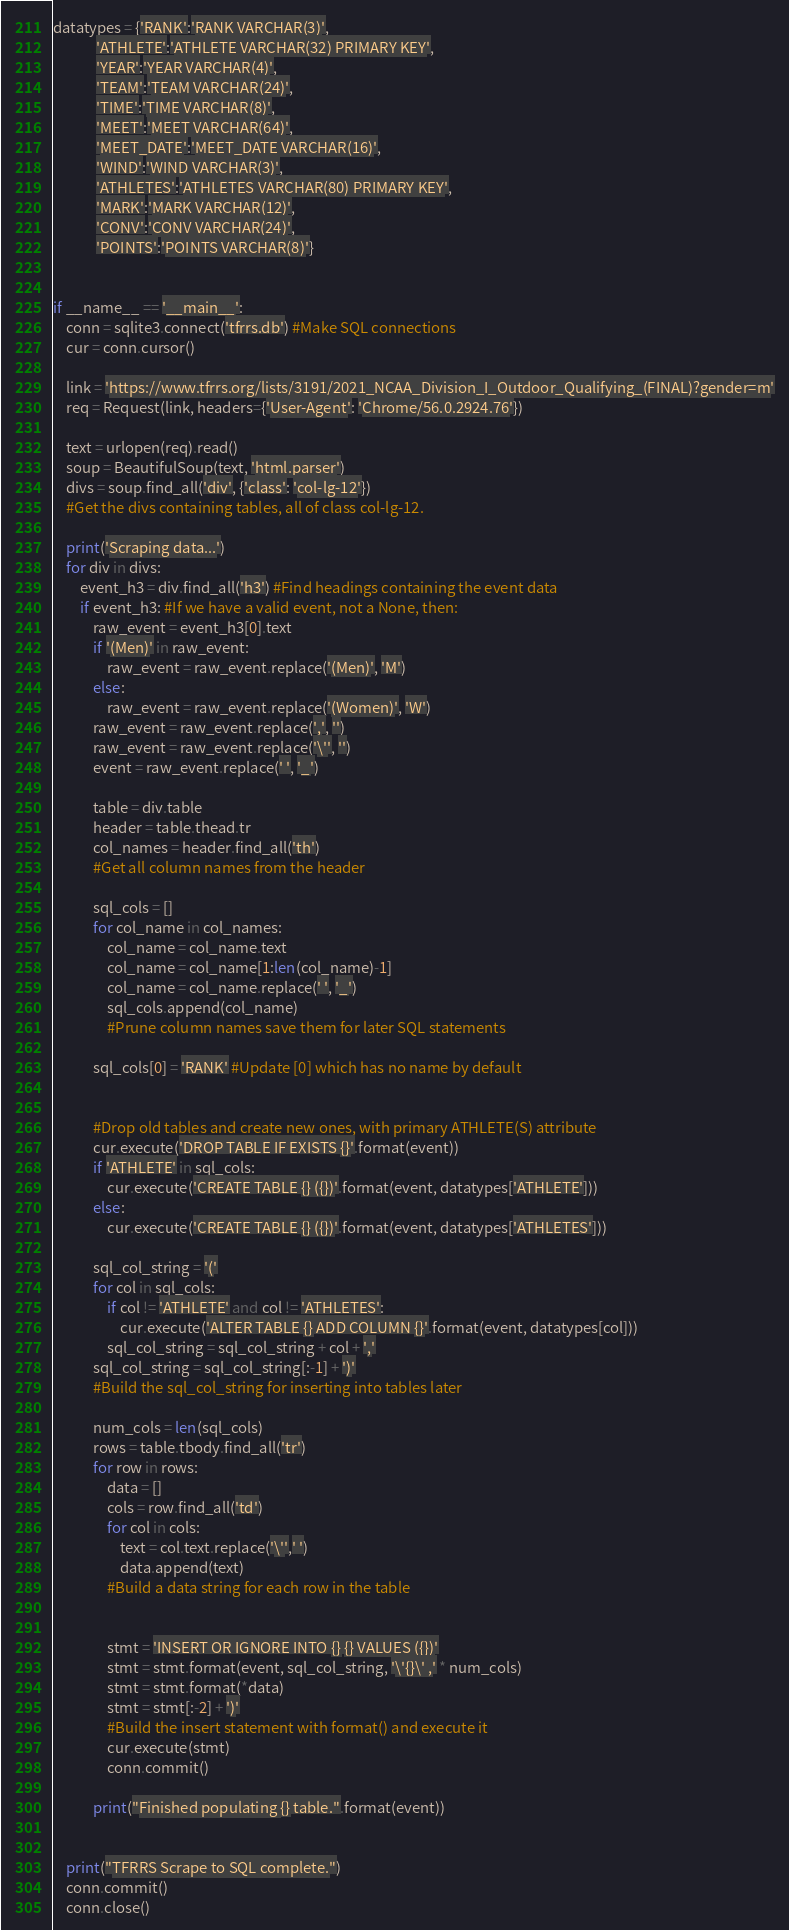<code> <loc_0><loc_0><loc_500><loc_500><_Python_>datatypes = {'RANK':'RANK VARCHAR(3)',
             'ATHLETE':'ATHLETE VARCHAR(32) PRIMARY KEY',
             'YEAR':'YEAR VARCHAR(4)',
             'TEAM':'TEAM VARCHAR(24)',
             'TIME':'TIME VARCHAR(8)',
             'MEET':'MEET VARCHAR(64)',
             'MEET_DATE':'MEET_DATE VARCHAR(16)',
             'WIND':'WIND VARCHAR(3)',
             'ATHLETES':'ATHLETES VARCHAR(80) PRIMARY KEY',
             'MARK':'MARK VARCHAR(12)',
             'CONV':'CONV VARCHAR(24)',
             'POINTS':'POINTS VARCHAR(8)'}


if __name__ == '__main__':
    conn = sqlite3.connect('tfrrs.db') #Make SQL connections
    cur = conn.cursor()

    link = 'https://www.tfrrs.org/lists/3191/2021_NCAA_Division_I_Outdoor_Qualifying_(FINAL)?gender=m'
    req = Request(link, headers={'User-Agent': 'Chrome/56.0.2924.76'})

    text = urlopen(req).read()
    soup = BeautifulSoup(text, 'html.parser')
    divs = soup.find_all('div', {'class': 'col-lg-12'})
    #Get the divs containing tables, all of class col-lg-12.

    print('Scraping data...')
    for div in divs:
        event_h3 = div.find_all('h3') #Find headings containing the event data
        if event_h3: #If we have a valid event, not a None, then:
            raw_event = event_h3[0].text
            if '(Men)' in raw_event:
                raw_event = raw_event.replace('(Men)', 'M')
            else:
                raw_event = raw_event.replace('(Women)', 'W')
            raw_event = raw_event.replace(',', '')
            raw_event = raw_event.replace('\'', '')
            event = raw_event.replace(' ', '_')

            table = div.table
            header = table.thead.tr
            col_names = header.find_all('th')
            #Get all column names from the header

            sql_cols = []
            for col_name in col_names:
                col_name = col_name.text
                col_name = col_name[1:len(col_name)-1]
                col_name = col_name.replace(' ', '_')
                sql_cols.append(col_name)
                #Prune column names save them for later SQL statements

            sql_cols[0] = 'RANK' #Update [0] which has no name by default


            #Drop old tables and create new ones, with primary ATHLETE(S) attribute
            cur.execute('DROP TABLE IF EXISTS {}'.format(event))
            if 'ATHLETE' in sql_cols:
                cur.execute('CREATE TABLE {} ({})'.format(event, datatypes['ATHLETE']))
            else:
                cur.execute('CREATE TABLE {} ({})'.format(event, datatypes['ATHLETES']))

            sql_col_string = '('
            for col in sql_cols:
                if col != 'ATHLETE' and col != 'ATHLETES':
                    cur.execute('ALTER TABLE {} ADD COLUMN {}'.format(event, datatypes[col]))
                sql_col_string = sql_col_string + col + ','
            sql_col_string = sql_col_string[:-1] + ')'
            #Build the sql_col_string for inserting into tables later

            num_cols = len(sql_cols)
            rows = table.tbody.find_all('tr')
            for row in rows:
                data = []
                cols = row.find_all('td')
                for col in cols:
                    text = col.text.replace('\'',' ')
                    data.append(text)
                #Build a data string for each row in the table


                stmt = 'INSERT OR IGNORE INTO {} {} VALUES ({})'
                stmt = stmt.format(event, sql_col_string, '\'{}\' ,' * num_cols)
                stmt = stmt.format(*data)
                stmt = stmt[:-2] + ')'
                #Build the insert statement with format() and execute it
                cur.execute(stmt)
                conn.commit()

            print("Finished populating {} table.".format(event))


    print("TFRRS Scrape to SQL complete.")
    conn.commit()
    conn.close()
</code> 